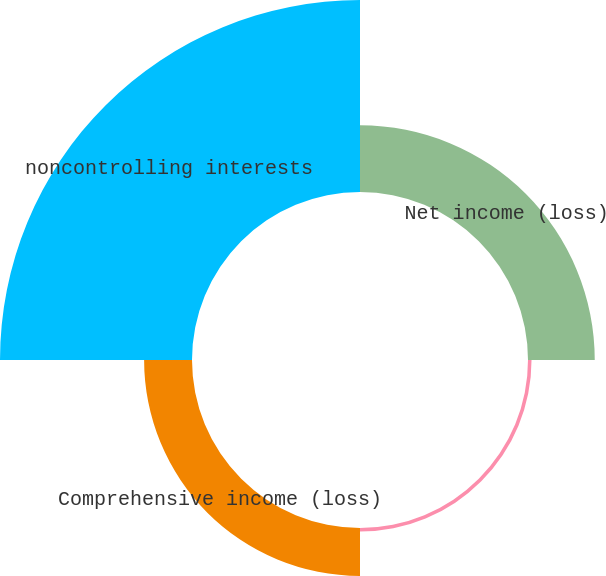Convert chart. <chart><loc_0><loc_0><loc_500><loc_500><pie_chart><fcel>Net income (loss)<fcel>Other comprehensive income<fcel>Comprehensive income (loss)<fcel>noncontrolling interests<nl><fcel>21.52%<fcel>1.14%<fcel>15.44%<fcel>61.91%<nl></chart> 